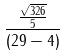<formula> <loc_0><loc_0><loc_500><loc_500>\frac { \frac { \sqrt { 3 2 6 } } { 5 } } { ( 2 9 - 4 ) }</formula> 